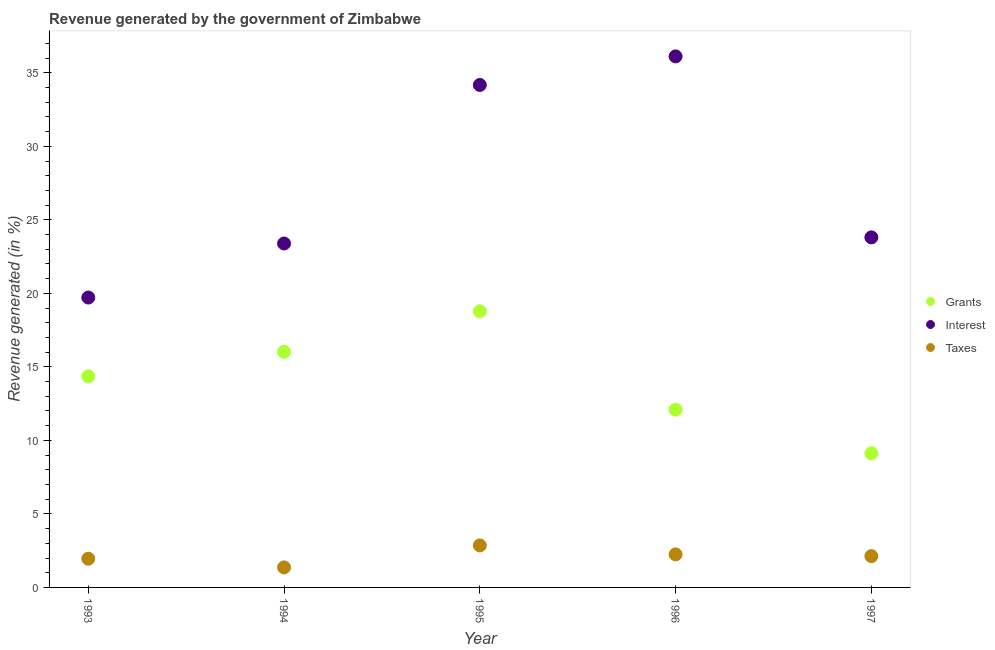How many different coloured dotlines are there?
Provide a short and direct response. 3. Is the number of dotlines equal to the number of legend labels?
Make the answer very short. Yes. What is the percentage of revenue generated by taxes in 1994?
Ensure brevity in your answer.  1.36. Across all years, what is the maximum percentage of revenue generated by grants?
Provide a short and direct response. 18.78. Across all years, what is the minimum percentage of revenue generated by interest?
Your answer should be very brief. 19.72. In which year was the percentage of revenue generated by interest minimum?
Offer a very short reply. 1993. What is the total percentage of revenue generated by interest in the graph?
Ensure brevity in your answer.  137.21. What is the difference between the percentage of revenue generated by grants in 1994 and that in 1995?
Make the answer very short. -2.75. What is the difference between the percentage of revenue generated by grants in 1994 and the percentage of revenue generated by interest in 1993?
Give a very brief answer. -3.69. What is the average percentage of revenue generated by grants per year?
Provide a short and direct response. 14.07. In the year 1997, what is the difference between the percentage of revenue generated by interest and percentage of revenue generated by taxes?
Your answer should be very brief. 21.68. In how many years, is the percentage of revenue generated by taxes greater than 32 %?
Provide a succinct answer. 0. What is the ratio of the percentage of revenue generated by grants in 1996 to that in 1997?
Give a very brief answer. 1.32. What is the difference between the highest and the second highest percentage of revenue generated by interest?
Provide a short and direct response. 1.94. What is the difference between the highest and the lowest percentage of revenue generated by taxes?
Provide a short and direct response. 1.5. Is it the case that in every year, the sum of the percentage of revenue generated by grants and percentage of revenue generated by interest is greater than the percentage of revenue generated by taxes?
Your response must be concise. Yes. Does the percentage of revenue generated by interest monotonically increase over the years?
Your answer should be compact. No. How many dotlines are there?
Offer a very short reply. 3. How many years are there in the graph?
Offer a terse response. 5. What is the difference between two consecutive major ticks on the Y-axis?
Provide a succinct answer. 5. Does the graph contain any zero values?
Your answer should be very brief. No. How many legend labels are there?
Ensure brevity in your answer.  3. How are the legend labels stacked?
Provide a short and direct response. Vertical. What is the title of the graph?
Offer a terse response. Revenue generated by the government of Zimbabwe. What is the label or title of the Y-axis?
Your answer should be very brief. Revenue generated (in %). What is the Revenue generated (in %) in Grants in 1993?
Offer a very short reply. 14.35. What is the Revenue generated (in %) in Interest in 1993?
Your answer should be very brief. 19.72. What is the Revenue generated (in %) in Taxes in 1993?
Offer a terse response. 1.95. What is the Revenue generated (in %) of Grants in 1994?
Offer a very short reply. 16.02. What is the Revenue generated (in %) of Interest in 1994?
Offer a terse response. 23.39. What is the Revenue generated (in %) of Taxes in 1994?
Offer a terse response. 1.36. What is the Revenue generated (in %) in Grants in 1995?
Your response must be concise. 18.78. What is the Revenue generated (in %) in Interest in 1995?
Offer a very short reply. 34.17. What is the Revenue generated (in %) of Taxes in 1995?
Provide a succinct answer. 2.86. What is the Revenue generated (in %) in Grants in 1996?
Your answer should be compact. 12.09. What is the Revenue generated (in %) of Interest in 1996?
Your answer should be very brief. 36.12. What is the Revenue generated (in %) of Taxes in 1996?
Offer a very short reply. 2.25. What is the Revenue generated (in %) of Grants in 1997?
Make the answer very short. 9.13. What is the Revenue generated (in %) of Interest in 1997?
Give a very brief answer. 23.81. What is the Revenue generated (in %) in Taxes in 1997?
Ensure brevity in your answer.  2.13. Across all years, what is the maximum Revenue generated (in %) of Grants?
Provide a short and direct response. 18.78. Across all years, what is the maximum Revenue generated (in %) in Interest?
Provide a short and direct response. 36.12. Across all years, what is the maximum Revenue generated (in %) in Taxes?
Provide a short and direct response. 2.86. Across all years, what is the minimum Revenue generated (in %) in Grants?
Your answer should be very brief. 9.13. Across all years, what is the minimum Revenue generated (in %) of Interest?
Your response must be concise. 19.72. Across all years, what is the minimum Revenue generated (in %) of Taxes?
Provide a succinct answer. 1.36. What is the total Revenue generated (in %) of Grants in the graph?
Keep it short and to the point. 70.37. What is the total Revenue generated (in %) in Interest in the graph?
Offer a terse response. 137.21. What is the total Revenue generated (in %) of Taxes in the graph?
Make the answer very short. 10.55. What is the difference between the Revenue generated (in %) of Grants in 1993 and that in 1994?
Your response must be concise. -1.67. What is the difference between the Revenue generated (in %) in Interest in 1993 and that in 1994?
Your answer should be compact. -3.68. What is the difference between the Revenue generated (in %) of Taxes in 1993 and that in 1994?
Make the answer very short. 0.59. What is the difference between the Revenue generated (in %) of Grants in 1993 and that in 1995?
Your response must be concise. -4.42. What is the difference between the Revenue generated (in %) of Interest in 1993 and that in 1995?
Give a very brief answer. -14.46. What is the difference between the Revenue generated (in %) in Taxes in 1993 and that in 1995?
Offer a very short reply. -0.9. What is the difference between the Revenue generated (in %) of Grants in 1993 and that in 1996?
Give a very brief answer. 2.27. What is the difference between the Revenue generated (in %) in Interest in 1993 and that in 1996?
Provide a short and direct response. -16.4. What is the difference between the Revenue generated (in %) of Taxes in 1993 and that in 1996?
Offer a terse response. -0.29. What is the difference between the Revenue generated (in %) in Grants in 1993 and that in 1997?
Offer a terse response. 5.23. What is the difference between the Revenue generated (in %) in Interest in 1993 and that in 1997?
Ensure brevity in your answer.  -4.09. What is the difference between the Revenue generated (in %) of Taxes in 1993 and that in 1997?
Keep it short and to the point. -0.18. What is the difference between the Revenue generated (in %) of Grants in 1994 and that in 1995?
Offer a very short reply. -2.75. What is the difference between the Revenue generated (in %) in Interest in 1994 and that in 1995?
Offer a very short reply. -10.78. What is the difference between the Revenue generated (in %) in Taxes in 1994 and that in 1995?
Make the answer very short. -1.5. What is the difference between the Revenue generated (in %) in Grants in 1994 and that in 1996?
Your answer should be very brief. 3.94. What is the difference between the Revenue generated (in %) in Interest in 1994 and that in 1996?
Give a very brief answer. -12.73. What is the difference between the Revenue generated (in %) of Taxes in 1994 and that in 1996?
Make the answer very short. -0.89. What is the difference between the Revenue generated (in %) of Grants in 1994 and that in 1997?
Keep it short and to the point. 6.9. What is the difference between the Revenue generated (in %) in Interest in 1994 and that in 1997?
Offer a very short reply. -0.42. What is the difference between the Revenue generated (in %) of Taxes in 1994 and that in 1997?
Keep it short and to the point. -0.77. What is the difference between the Revenue generated (in %) in Grants in 1995 and that in 1996?
Your answer should be very brief. 6.69. What is the difference between the Revenue generated (in %) of Interest in 1995 and that in 1996?
Ensure brevity in your answer.  -1.94. What is the difference between the Revenue generated (in %) of Taxes in 1995 and that in 1996?
Your answer should be very brief. 0.61. What is the difference between the Revenue generated (in %) in Grants in 1995 and that in 1997?
Provide a short and direct response. 9.65. What is the difference between the Revenue generated (in %) in Interest in 1995 and that in 1997?
Provide a succinct answer. 10.37. What is the difference between the Revenue generated (in %) in Taxes in 1995 and that in 1997?
Give a very brief answer. 0.73. What is the difference between the Revenue generated (in %) of Grants in 1996 and that in 1997?
Your answer should be compact. 2.96. What is the difference between the Revenue generated (in %) of Interest in 1996 and that in 1997?
Provide a succinct answer. 12.31. What is the difference between the Revenue generated (in %) in Taxes in 1996 and that in 1997?
Give a very brief answer. 0.12. What is the difference between the Revenue generated (in %) of Grants in 1993 and the Revenue generated (in %) of Interest in 1994?
Your answer should be compact. -9.04. What is the difference between the Revenue generated (in %) of Grants in 1993 and the Revenue generated (in %) of Taxes in 1994?
Make the answer very short. 12.99. What is the difference between the Revenue generated (in %) in Interest in 1993 and the Revenue generated (in %) in Taxes in 1994?
Your answer should be very brief. 18.36. What is the difference between the Revenue generated (in %) of Grants in 1993 and the Revenue generated (in %) of Interest in 1995?
Your answer should be very brief. -19.82. What is the difference between the Revenue generated (in %) of Grants in 1993 and the Revenue generated (in %) of Taxes in 1995?
Provide a succinct answer. 11.5. What is the difference between the Revenue generated (in %) of Interest in 1993 and the Revenue generated (in %) of Taxes in 1995?
Your answer should be very brief. 16.86. What is the difference between the Revenue generated (in %) of Grants in 1993 and the Revenue generated (in %) of Interest in 1996?
Provide a short and direct response. -21.76. What is the difference between the Revenue generated (in %) in Grants in 1993 and the Revenue generated (in %) in Taxes in 1996?
Provide a short and direct response. 12.11. What is the difference between the Revenue generated (in %) in Interest in 1993 and the Revenue generated (in %) in Taxes in 1996?
Make the answer very short. 17.47. What is the difference between the Revenue generated (in %) of Grants in 1993 and the Revenue generated (in %) of Interest in 1997?
Provide a succinct answer. -9.45. What is the difference between the Revenue generated (in %) in Grants in 1993 and the Revenue generated (in %) in Taxes in 1997?
Keep it short and to the point. 12.22. What is the difference between the Revenue generated (in %) of Interest in 1993 and the Revenue generated (in %) of Taxes in 1997?
Give a very brief answer. 17.59. What is the difference between the Revenue generated (in %) of Grants in 1994 and the Revenue generated (in %) of Interest in 1995?
Make the answer very short. -18.15. What is the difference between the Revenue generated (in %) in Grants in 1994 and the Revenue generated (in %) in Taxes in 1995?
Make the answer very short. 13.17. What is the difference between the Revenue generated (in %) of Interest in 1994 and the Revenue generated (in %) of Taxes in 1995?
Ensure brevity in your answer.  20.53. What is the difference between the Revenue generated (in %) of Grants in 1994 and the Revenue generated (in %) of Interest in 1996?
Make the answer very short. -20.09. What is the difference between the Revenue generated (in %) in Grants in 1994 and the Revenue generated (in %) in Taxes in 1996?
Offer a terse response. 13.78. What is the difference between the Revenue generated (in %) in Interest in 1994 and the Revenue generated (in %) in Taxes in 1996?
Your response must be concise. 21.15. What is the difference between the Revenue generated (in %) in Grants in 1994 and the Revenue generated (in %) in Interest in 1997?
Your answer should be compact. -7.78. What is the difference between the Revenue generated (in %) of Grants in 1994 and the Revenue generated (in %) of Taxes in 1997?
Keep it short and to the point. 13.9. What is the difference between the Revenue generated (in %) of Interest in 1994 and the Revenue generated (in %) of Taxes in 1997?
Your response must be concise. 21.26. What is the difference between the Revenue generated (in %) in Grants in 1995 and the Revenue generated (in %) in Interest in 1996?
Your response must be concise. -17.34. What is the difference between the Revenue generated (in %) of Grants in 1995 and the Revenue generated (in %) of Taxes in 1996?
Your response must be concise. 16.53. What is the difference between the Revenue generated (in %) of Interest in 1995 and the Revenue generated (in %) of Taxes in 1996?
Provide a short and direct response. 31.93. What is the difference between the Revenue generated (in %) in Grants in 1995 and the Revenue generated (in %) in Interest in 1997?
Make the answer very short. -5.03. What is the difference between the Revenue generated (in %) in Grants in 1995 and the Revenue generated (in %) in Taxes in 1997?
Your answer should be compact. 16.65. What is the difference between the Revenue generated (in %) in Interest in 1995 and the Revenue generated (in %) in Taxes in 1997?
Offer a very short reply. 32.04. What is the difference between the Revenue generated (in %) in Grants in 1996 and the Revenue generated (in %) in Interest in 1997?
Provide a succinct answer. -11.72. What is the difference between the Revenue generated (in %) in Grants in 1996 and the Revenue generated (in %) in Taxes in 1997?
Give a very brief answer. 9.96. What is the difference between the Revenue generated (in %) of Interest in 1996 and the Revenue generated (in %) of Taxes in 1997?
Make the answer very short. 33.99. What is the average Revenue generated (in %) in Grants per year?
Make the answer very short. 14.07. What is the average Revenue generated (in %) in Interest per year?
Ensure brevity in your answer.  27.44. What is the average Revenue generated (in %) of Taxes per year?
Provide a short and direct response. 2.11. In the year 1993, what is the difference between the Revenue generated (in %) of Grants and Revenue generated (in %) of Interest?
Provide a short and direct response. -5.36. In the year 1993, what is the difference between the Revenue generated (in %) in Grants and Revenue generated (in %) in Taxes?
Make the answer very short. 12.4. In the year 1993, what is the difference between the Revenue generated (in %) in Interest and Revenue generated (in %) in Taxes?
Offer a very short reply. 17.76. In the year 1994, what is the difference between the Revenue generated (in %) of Grants and Revenue generated (in %) of Interest?
Keep it short and to the point. -7.37. In the year 1994, what is the difference between the Revenue generated (in %) of Grants and Revenue generated (in %) of Taxes?
Your response must be concise. 14.66. In the year 1994, what is the difference between the Revenue generated (in %) of Interest and Revenue generated (in %) of Taxes?
Your answer should be very brief. 22.03. In the year 1995, what is the difference between the Revenue generated (in %) of Grants and Revenue generated (in %) of Interest?
Your response must be concise. -15.4. In the year 1995, what is the difference between the Revenue generated (in %) in Grants and Revenue generated (in %) in Taxes?
Make the answer very short. 15.92. In the year 1995, what is the difference between the Revenue generated (in %) of Interest and Revenue generated (in %) of Taxes?
Give a very brief answer. 31.32. In the year 1996, what is the difference between the Revenue generated (in %) in Grants and Revenue generated (in %) in Interest?
Your answer should be very brief. -24.03. In the year 1996, what is the difference between the Revenue generated (in %) of Grants and Revenue generated (in %) of Taxes?
Make the answer very short. 9.84. In the year 1996, what is the difference between the Revenue generated (in %) of Interest and Revenue generated (in %) of Taxes?
Your answer should be very brief. 33.87. In the year 1997, what is the difference between the Revenue generated (in %) of Grants and Revenue generated (in %) of Interest?
Your response must be concise. -14.68. In the year 1997, what is the difference between the Revenue generated (in %) in Grants and Revenue generated (in %) in Taxes?
Your response must be concise. 7. In the year 1997, what is the difference between the Revenue generated (in %) of Interest and Revenue generated (in %) of Taxes?
Your response must be concise. 21.68. What is the ratio of the Revenue generated (in %) in Grants in 1993 to that in 1994?
Make the answer very short. 0.9. What is the ratio of the Revenue generated (in %) of Interest in 1993 to that in 1994?
Your response must be concise. 0.84. What is the ratio of the Revenue generated (in %) of Taxes in 1993 to that in 1994?
Offer a terse response. 1.44. What is the ratio of the Revenue generated (in %) in Grants in 1993 to that in 1995?
Offer a very short reply. 0.76. What is the ratio of the Revenue generated (in %) in Interest in 1993 to that in 1995?
Offer a terse response. 0.58. What is the ratio of the Revenue generated (in %) in Taxes in 1993 to that in 1995?
Your response must be concise. 0.68. What is the ratio of the Revenue generated (in %) of Grants in 1993 to that in 1996?
Provide a short and direct response. 1.19. What is the ratio of the Revenue generated (in %) of Interest in 1993 to that in 1996?
Your response must be concise. 0.55. What is the ratio of the Revenue generated (in %) of Taxes in 1993 to that in 1996?
Keep it short and to the point. 0.87. What is the ratio of the Revenue generated (in %) of Grants in 1993 to that in 1997?
Ensure brevity in your answer.  1.57. What is the ratio of the Revenue generated (in %) in Interest in 1993 to that in 1997?
Offer a terse response. 0.83. What is the ratio of the Revenue generated (in %) in Taxes in 1993 to that in 1997?
Offer a very short reply. 0.92. What is the ratio of the Revenue generated (in %) of Grants in 1994 to that in 1995?
Your response must be concise. 0.85. What is the ratio of the Revenue generated (in %) of Interest in 1994 to that in 1995?
Provide a succinct answer. 0.68. What is the ratio of the Revenue generated (in %) of Taxes in 1994 to that in 1995?
Make the answer very short. 0.48. What is the ratio of the Revenue generated (in %) of Grants in 1994 to that in 1996?
Keep it short and to the point. 1.33. What is the ratio of the Revenue generated (in %) in Interest in 1994 to that in 1996?
Make the answer very short. 0.65. What is the ratio of the Revenue generated (in %) of Taxes in 1994 to that in 1996?
Give a very brief answer. 0.61. What is the ratio of the Revenue generated (in %) in Grants in 1994 to that in 1997?
Offer a very short reply. 1.76. What is the ratio of the Revenue generated (in %) of Interest in 1994 to that in 1997?
Keep it short and to the point. 0.98. What is the ratio of the Revenue generated (in %) of Taxes in 1994 to that in 1997?
Your answer should be compact. 0.64. What is the ratio of the Revenue generated (in %) of Grants in 1995 to that in 1996?
Provide a short and direct response. 1.55. What is the ratio of the Revenue generated (in %) of Interest in 1995 to that in 1996?
Offer a terse response. 0.95. What is the ratio of the Revenue generated (in %) of Taxes in 1995 to that in 1996?
Offer a very short reply. 1.27. What is the ratio of the Revenue generated (in %) in Grants in 1995 to that in 1997?
Ensure brevity in your answer.  2.06. What is the ratio of the Revenue generated (in %) in Interest in 1995 to that in 1997?
Provide a short and direct response. 1.44. What is the ratio of the Revenue generated (in %) in Taxes in 1995 to that in 1997?
Make the answer very short. 1.34. What is the ratio of the Revenue generated (in %) in Grants in 1996 to that in 1997?
Provide a succinct answer. 1.32. What is the ratio of the Revenue generated (in %) of Interest in 1996 to that in 1997?
Your response must be concise. 1.52. What is the ratio of the Revenue generated (in %) of Taxes in 1996 to that in 1997?
Your answer should be very brief. 1.05. What is the difference between the highest and the second highest Revenue generated (in %) in Grants?
Ensure brevity in your answer.  2.75. What is the difference between the highest and the second highest Revenue generated (in %) in Interest?
Your response must be concise. 1.94. What is the difference between the highest and the second highest Revenue generated (in %) of Taxes?
Offer a terse response. 0.61. What is the difference between the highest and the lowest Revenue generated (in %) in Grants?
Give a very brief answer. 9.65. What is the difference between the highest and the lowest Revenue generated (in %) of Interest?
Keep it short and to the point. 16.4. What is the difference between the highest and the lowest Revenue generated (in %) in Taxes?
Give a very brief answer. 1.5. 